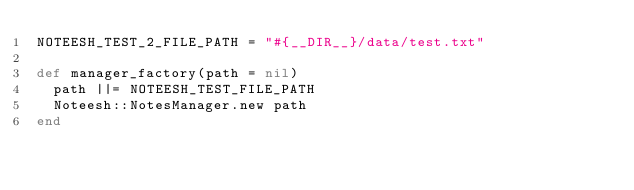Convert code to text. <code><loc_0><loc_0><loc_500><loc_500><_Crystal_>NOTEESH_TEST_2_FILE_PATH = "#{__DIR__}/data/test.txt"

def manager_factory(path = nil)
  path ||= NOTEESH_TEST_FILE_PATH
  Noteesh::NotesManager.new path
end
</code> 